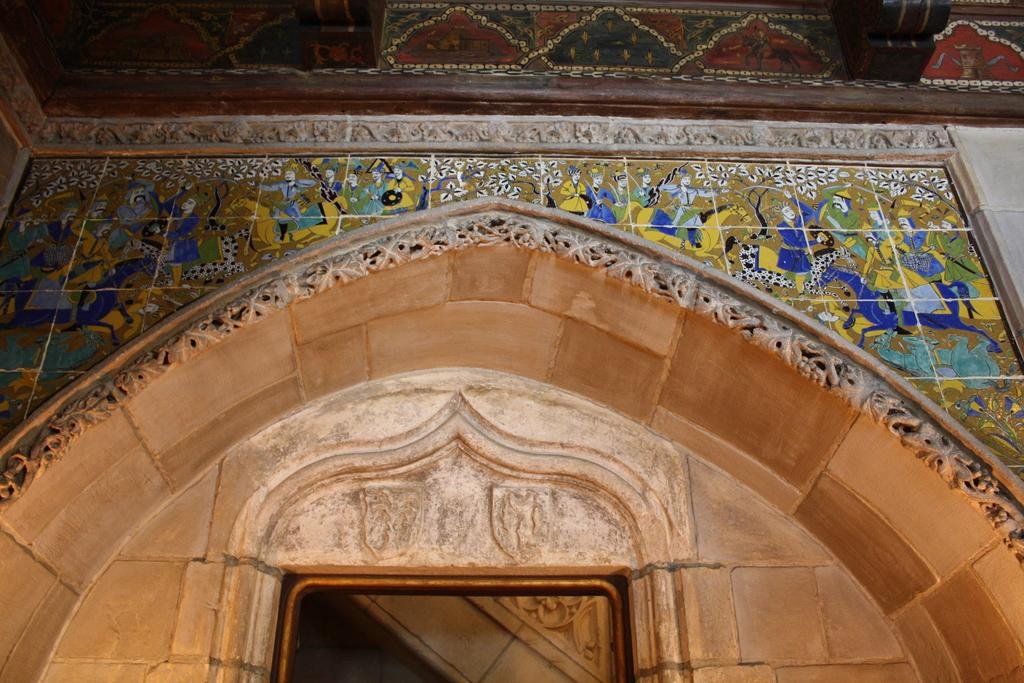What type of location is depicted in the image? The image shows the interior of a building. What design element can be seen on the wall? There are colorful tiles on the wall. How can someone enter or exit the building? There is an entrance door visible in the image. What part of the building is visible above the walls and door? The ceiling is present in the image. What type of furniture is being delivered to the building in the image? There is no furniture or parcel visible in the image; it only shows the interior of the building with colorful tiles, an entrance door, and a ceiling. 